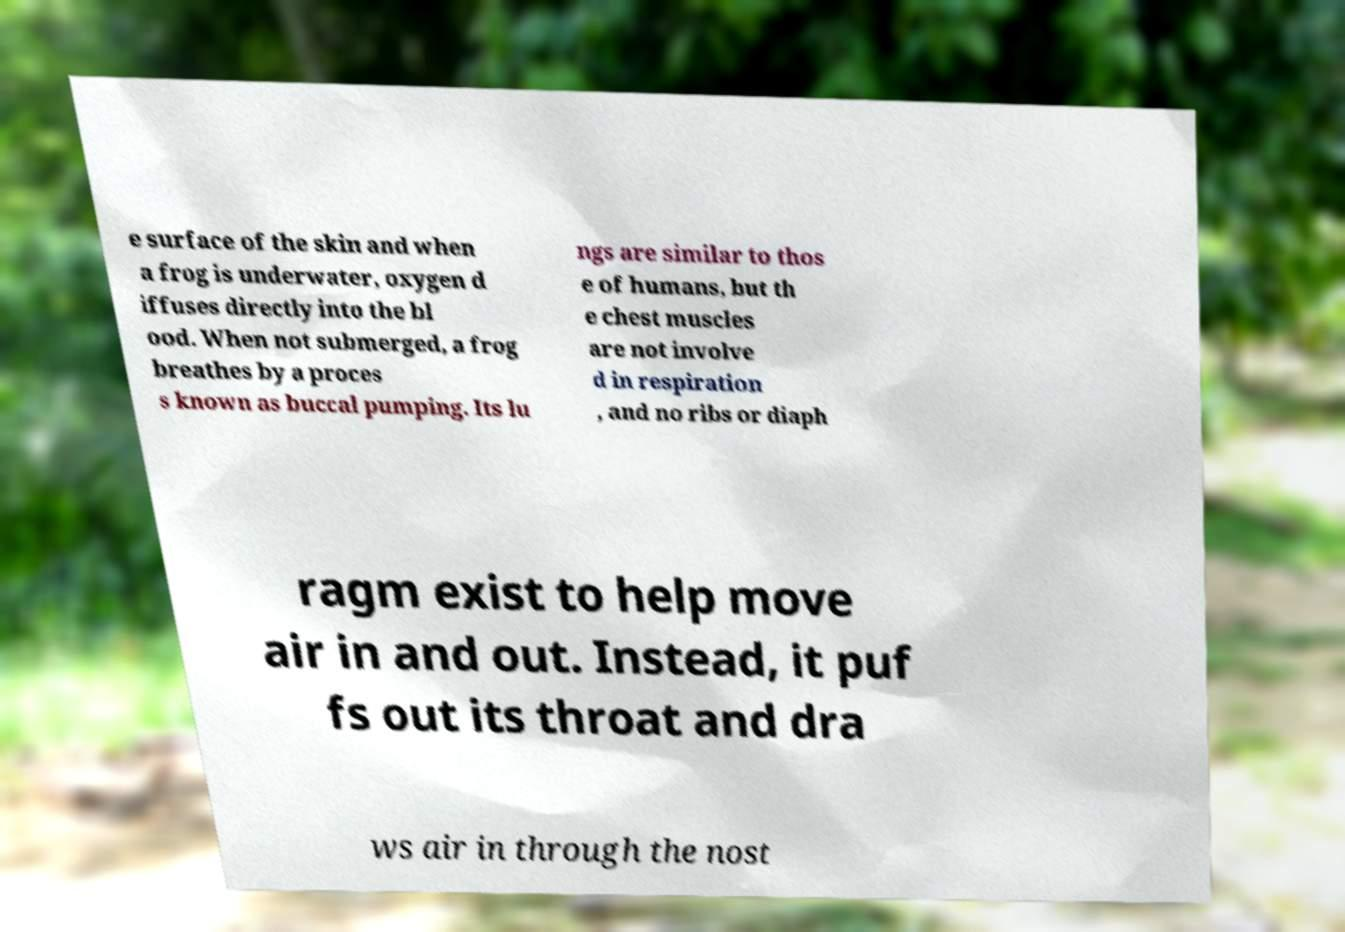Please identify and transcribe the text found in this image. e surface of the skin and when a frog is underwater, oxygen d iffuses directly into the bl ood. When not submerged, a frog breathes by a proces s known as buccal pumping. Its lu ngs are similar to thos e of humans, but th e chest muscles are not involve d in respiration , and no ribs or diaph ragm exist to help move air in and out. Instead, it puf fs out its throat and dra ws air in through the nost 